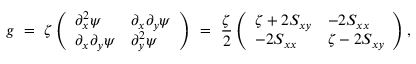Convert formula to latex. <formula><loc_0><loc_0><loc_500><loc_500>g \ = \ \zeta \left ( \begin{array} { l l } { \partial _ { x } ^ { 2 } \psi } & { \partial _ { x } \partial _ { y } \psi } \\ { \partial _ { x } \partial _ { y } \psi } & { \partial _ { y } ^ { 2 } \psi } \end{array} \right ) \ = \ \frac { \zeta } { 2 } \left ( \begin{array} { l l } { \zeta + 2 S _ { x y } } & { - 2 S _ { x x } } \\ { - 2 S _ { x x } } & { \zeta - 2 S _ { x y } } \end{array} \right ) ,</formula> 